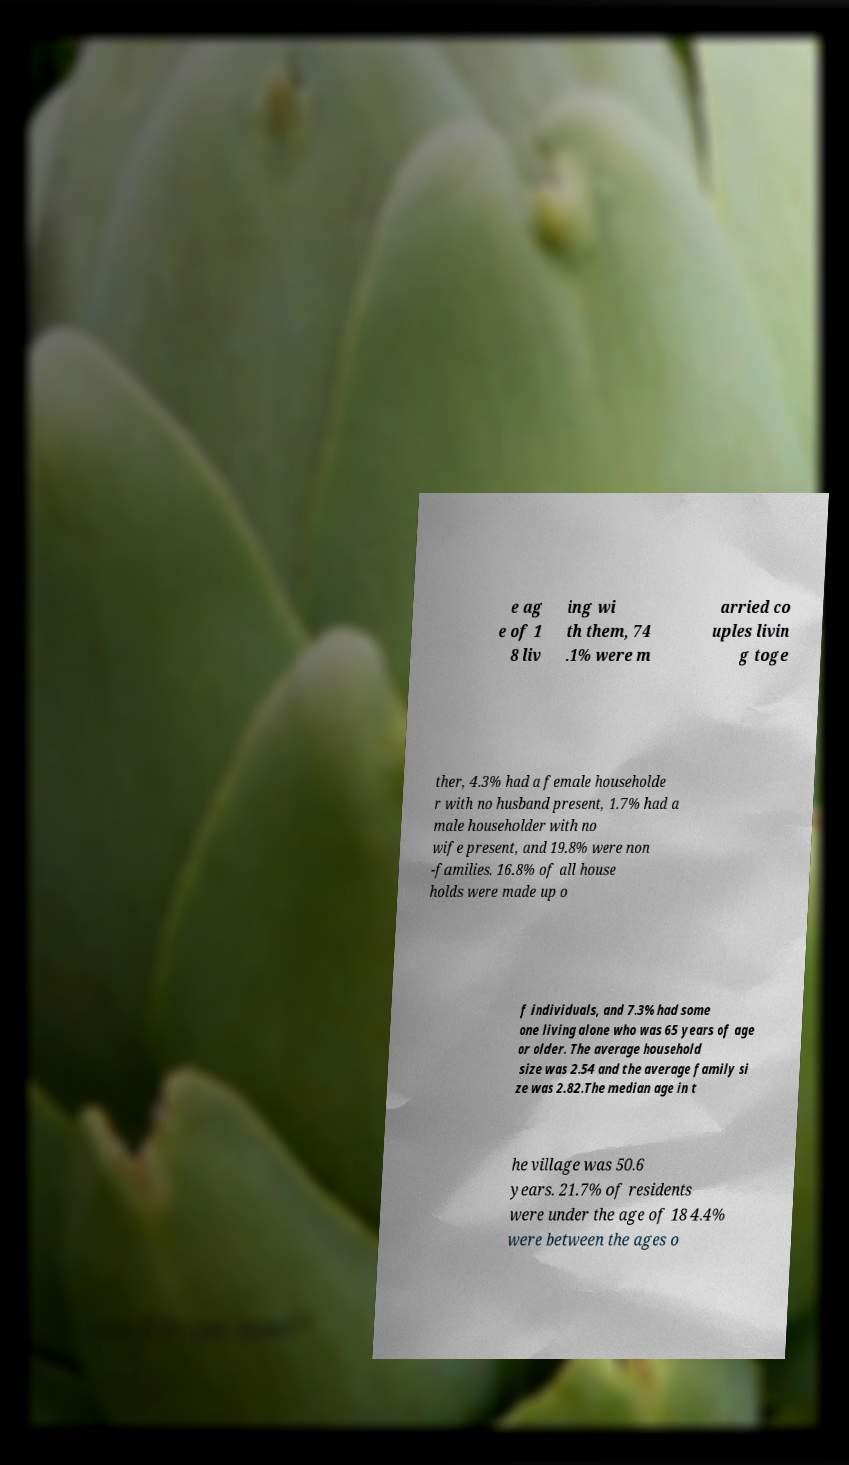For documentation purposes, I need the text within this image transcribed. Could you provide that? e ag e of 1 8 liv ing wi th them, 74 .1% were m arried co uples livin g toge ther, 4.3% had a female householde r with no husband present, 1.7% had a male householder with no wife present, and 19.8% were non -families. 16.8% of all house holds were made up o f individuals, and 7.3% had some one living alone who was 65 years of age or older. The average household size was 2.54 and the average family si ze was 2.82.The median age in t he village was 50.6 years. 21.7% of residents were under the age of 18 4.4% were between the ages o 